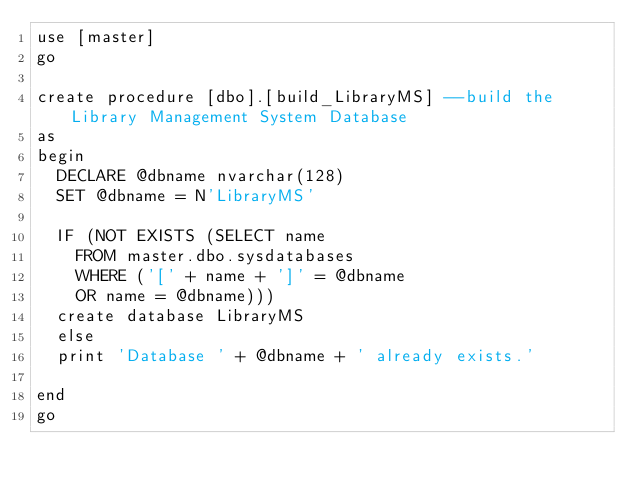<code> <loc_0><loc_0><loc_500><loc_500><_SQL_>use [master]
go

create procedure [dbo].[build_LibraryMS] --build the Library Management System Database
as
begin
	DECLARE @dbname nvarchar(128)
	SET @dbname = N'LibraryMS'

	IF (NOT EXISTS (SELECT name 
		FROM master.dbo.sysdatabases 
		WHERE ('[' + name + ']' = @dbname 
		OR name = @dbname)))
	create database LibraryMS
	else
	print 'Database ' + @dbname + ' already exists.'

end
go</code> 